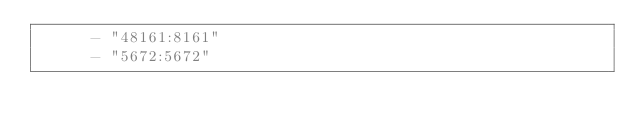<code> <loc_0><loc_0><loc_500><loc_500><_YAML_>      - "48161:8161"
      - "5672:5672"</code> 